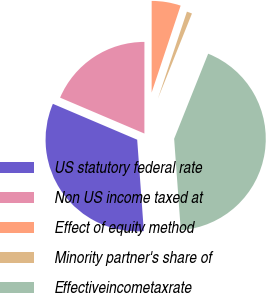<chart> <loc_0><loc_0><loc_500><loc_500><pie_chart><fcel>US statutory federal rate<fcel>Non US income taxed at<fcel>Effect of equity method<fcel>Minority partner's share of<fcel>Effectiveincometaxrate<nl><fcel>32.56%<fcel>18.6%<fcel>5.12%<fcel>0.93%<fcel>42.79%<nl></chart> 